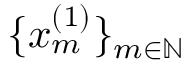Convert formula to latex. <formula><loc_0><loc_0><loc_500><loc_500>\{ x _ { m } ^ { ( 1 ) } \} _ { m \in \mathbb { N } }</formula> 